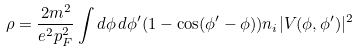<formula> <loc_0><loc_0><loc_500><loc_500>\rho = \frac { 2 m ^ { 2 } } { e ^ { 2 } p _ { F } ^ { 2 } } \int d \phi \, d \phi ^ { \prime } ( 1 - \cos ( \phi ^ { \prime } - \phi ) ) n _ { i } | V ( \phi , \phi ^ { \prime } ) | ^ { 2 }</formula> 